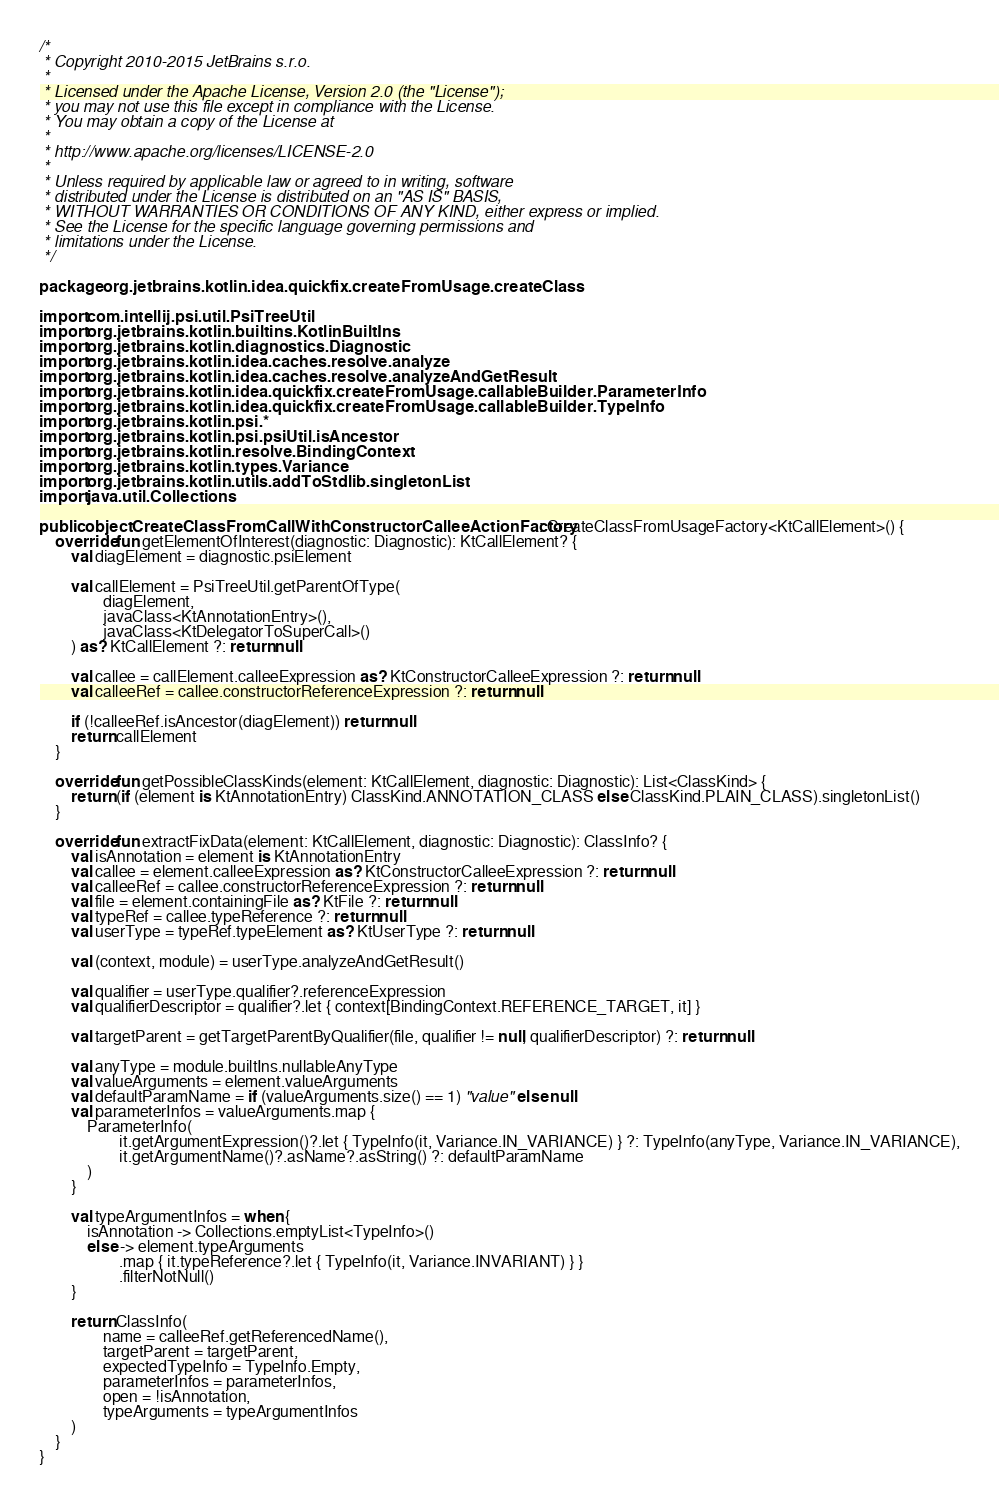Convert code to text. <code><loc_0><loc_0><loc_500><loc_500><_Kotlin_>/*
 * Copyright 2010-2015 JetBrains s.r.o.
 *
 * Licensed under the Apache License, Version 2.0 (the "License");
 * you may not use this file except in compliance with the License.
 * You may obtain a copy of the License at
 *
 * http://www.apache.org/licenses/LICENSE-2.0
 *
 * Unless required by applicable law or agreed to in writing, software
 * distributed under the License is distributed on an "AS IS" BASIS,
 * WITHOUT WARRANTIES OR CONDITIONS OF ANY KIND, either express or implied.
 * See the License for the specific language governing permissions and
 * limitations under the License.
 */

package org.jetbrains.kotlin.idea.quickfix.createFromUsage.createClass

import com.intellij.psi.util.PsiTreeUtil
import org.jetbrains.kotlin.builtins.KotlinBuiltIns
import org.jetbrains.kotlin.diagnostics.Diagnostic
import org.jetbrains.kotlin.idea.caches.resolve.analyze
import org.jetbrains.kotlin.idea.caches.resolve.analyzeAndGetResult
import org.jetbrains.kotlin.idea.quickfix.createFromUsage.callableBuilder.ParameterInfo
import org.jetbrains.kotlin.idea.quickfix.createFromUsage.callableBuilder.TypeInfo
import org.jetbrains.kotlin.psi.*
import org.jetbrains.kotlin.psi.psiUtil.isAncestor
import org.jetbrains.kotlin.resolve.BindingContext
import org.jetbrains.kotlin.types.Variance
import org.jetbrains.kotlin.utils.addToStdlib.singletonList
import java.util.Collections

public object CreateClassFromCallWithConstructorCalleeActionFactory : CreateClassFromUsageFactory<KtCallElement>() {
    override fun getElementOfInterest(diagnostic: Diagnostic): KtCallElement? {
        val diagElement = diagnostic.psiElement

        val callElement = PsiTreeUtil.getParentOfType(
                diagElement,
                javaClass<KtAnnotationEntry>(),
                javaClass<KtDelegatorToSuperCall>()
        ) as? KtCallElement ?: return null

        val callee = callElement.calleeExpression as? KtConstructorCalleeExpression ?: return null
        val calleeRef = callee.constructorReferenceExpression ?: return null

        if (!calleeRef.isAncestor(diagElement)) return null
        return callElement
    }

    override fun getPossibleClassKinds(element: KtCallElement, diagnostic: Diagnostic): List<ClassKind> {
        return (if (element is KtAnnotationEntry) ClassKind.ANNOTATION_CLASS else ClassKind.PLAIN_CLASS).singletonList()
    }

    override fun extractFixData(element: KtCallElement, diagnostic: Diagnostic): ClassInfo? {
        val isAnnotation = element is KtAnnotationEntry
        val callee = element.calleeExpression as? KtConstructorCalleeExpression ?: return null
        val calleeRef = callee.constructorReferenceExpression ?: return null
        val file = element.containingFile as? KtFile ?: return null
        val typeRef = callee.typeReference ?: return null
        val userType = typeRef.typeElement as? KtUserType ?: return null

        val (context, module) = userType.analyzeAndGetResult()

        val qualifier = userType.qualifier?.referenceExpression
        val qualifierDescriptor = qualifier?.let { context[BindingContext.REFERENCE_TARGET, it] }

        val targetParent = getTargetParentByQualifier(file, qualifier != null, qualifierDescriptor) ?: return null

        val anyType = module.builtIns.nullableAnyType
        val valueArguments = element.valueArguments
        val defaultParamName = if (valueArguments.size() == 1) "value" else null
        val parameterInfos = valueArguments.map {
            ParameterInfo(
                    it.getArgumentExpression()?.let { TypeInfo(it, Variance.IN_VARIANCE) } ?: TypeInfo(anyType, Variance.IN_VARIANCE),
                    it.getArgumentName()?.asName?.asString() ?: defaultParamName
            )
        }

        val typeArgumentInfos = when {
            isAnnotation -> Collections.emptyList<TypeInfo>()
            else -> element.typeArguments
                    .map { it.typeReference?.let { TypeInfo(it, Variance.INVARIANT) } }
                    .filterNotNull()
        }

        return ClassInfo(
                name = calleeRef.getReferencedName(),
                targetParent = targetParent,
                expectedTypeInfo = TypeInfo.Empty,
                parameterInfos = parameterInfos,
                open = !isAnnotation,
                typeArguments = typeArgumentInfos
        )
    }
}
</code> 